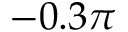Convert formula to latex. <formula><loc_0><loc_0><loc_500><loc_500>- 0 . 3 \pi</formula> 